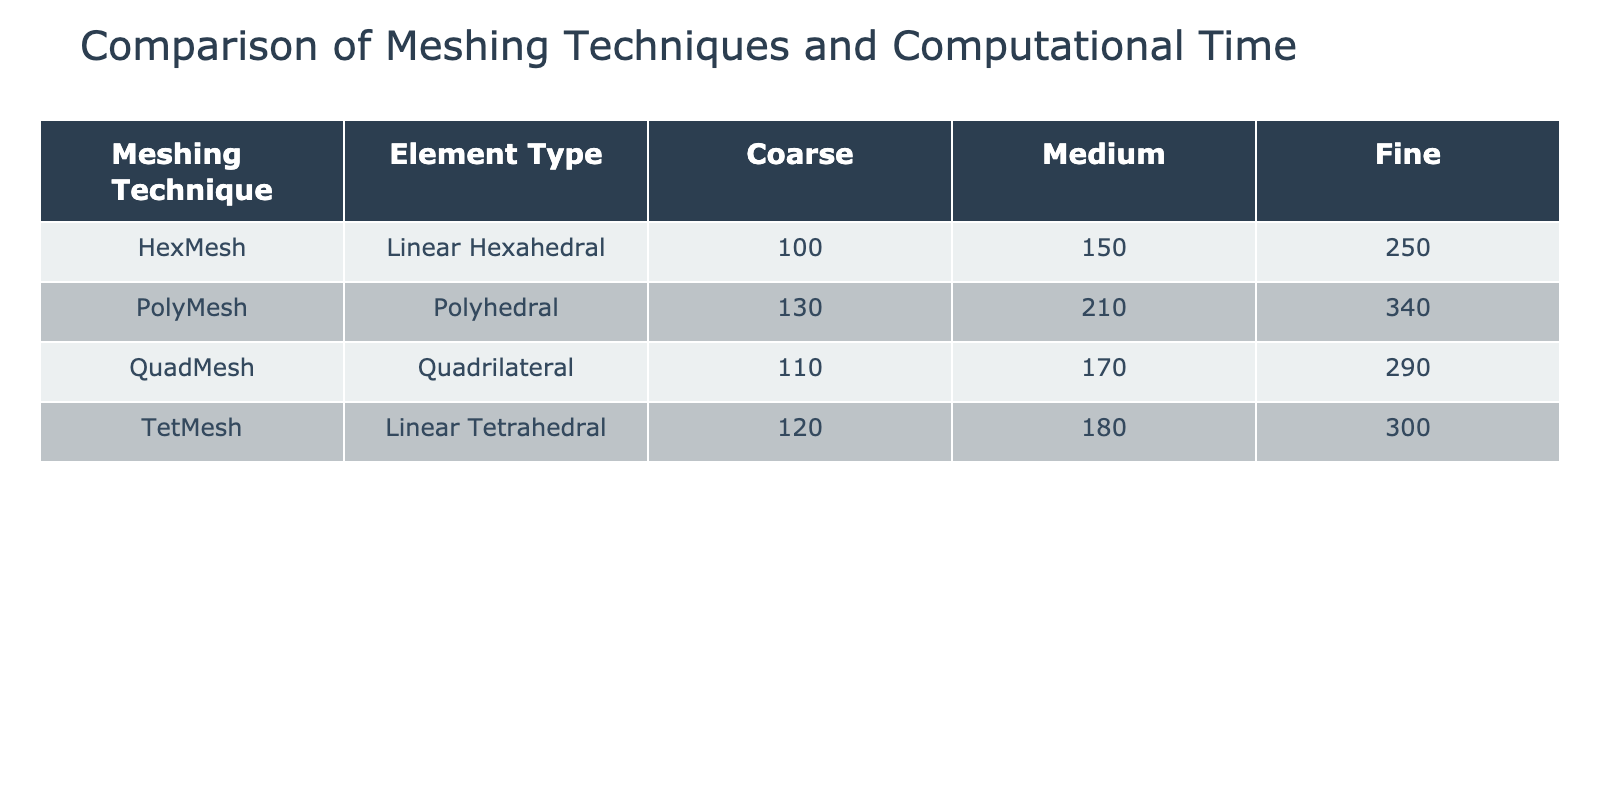What is the computational time for the HexMesh with Fine mesh size? The table shows the computational time for each meshing technique and its respective mesh size. Looking under the HexMesh row and Fine column, the value recorded is 250 seconds.
Answer: 250 seconds Which meshing technique has the highest computational time with a Medium mesh size? The table can be reviewed by checking the Medium column for each meshing technique. The values are: TetMesh (180), HexMesh (150), QuadMesh (170), and PolyMesh (210). The highest value, 210 seconds, corresponds to PolyMesh.
Answer: PolyMesh What is the average computational time for the Coarse mesh sizes across all meshing techniques? To find the average, sum the computational times for the Coarse mesh sizes: TetMesh (120) + HexMesh (100) + QuadMesh (110) + PolyMesh (130) = 460 seconds. There are 4 techniques, so the average is 460 / 4 = 115.
Answer: 115 seconds Is the computational time for Fine mesh size always greater than for Coarse mesh size? We need to compare the values for each meshing technique. For TetMesh: Fine (300) > Coarse (120), HexMesh: Fine (250) > Coarse (100), QuadMesh: Fine (290) > Coarse (110), and PolyMesh: Fine (340) > Coarse (130). All comparisons confirm that Fine is always greater than Coarse.
Answer: Yes How much more time does the PolyMesh with Fine mesh size take compared to the HexMesh with Medium mesh size? From the table, PolyMesh Fine takes 340 seconds and HexMesh Medium takes 150 seconds. The difference is 340 - 150 = 190 seconds.
Answer: 190 seconds 